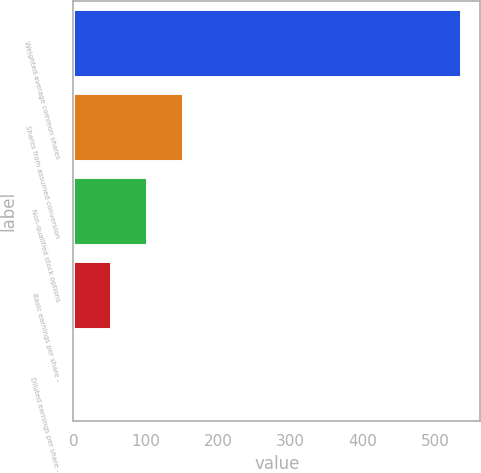Convert chart to OTSL. <chart><loc_0><loc_0><loc_500><loc_500><bar_chart><fcel>Weighted-average common shares<fcel>Shares from assumed conversion<fcel>Non-qualified stock options<fcel>Basic earnings per share -<fcel>Diluted earnings per share -<nl><fcel>534.92<fcel>151.37<fcel>101.45<fcel>51.53<fcel>1.61<nl></chart> 